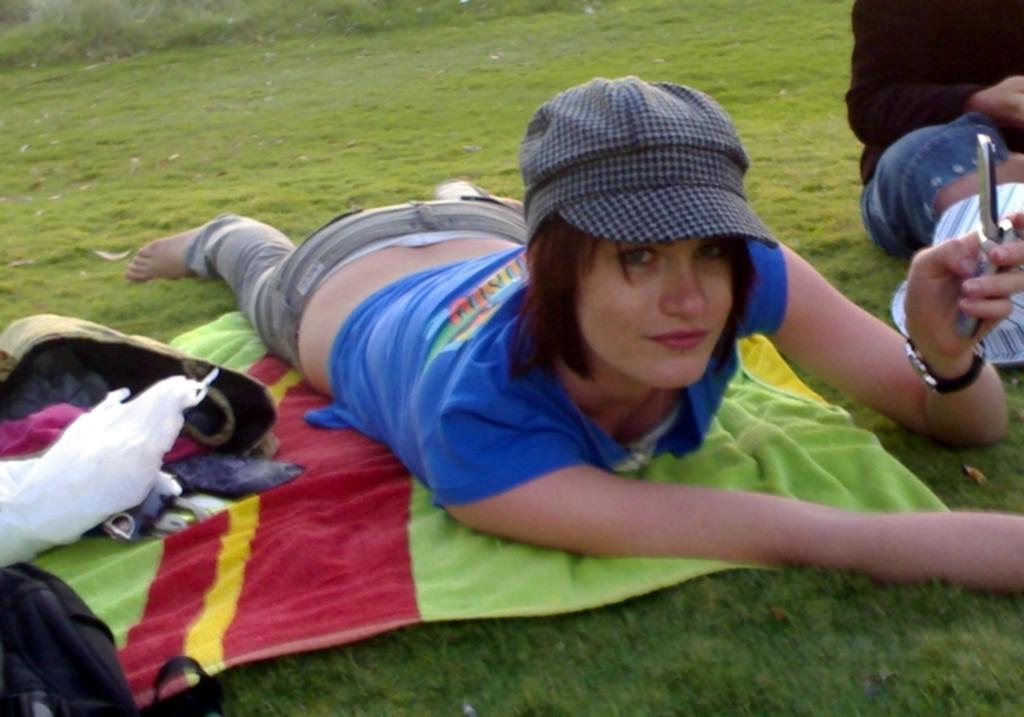Could you give a brief overview of what you see in this image? In this image we can see a lady is lying on the towel. She is wearing a blue color dress and a cap and holding a mobile in her hand. 